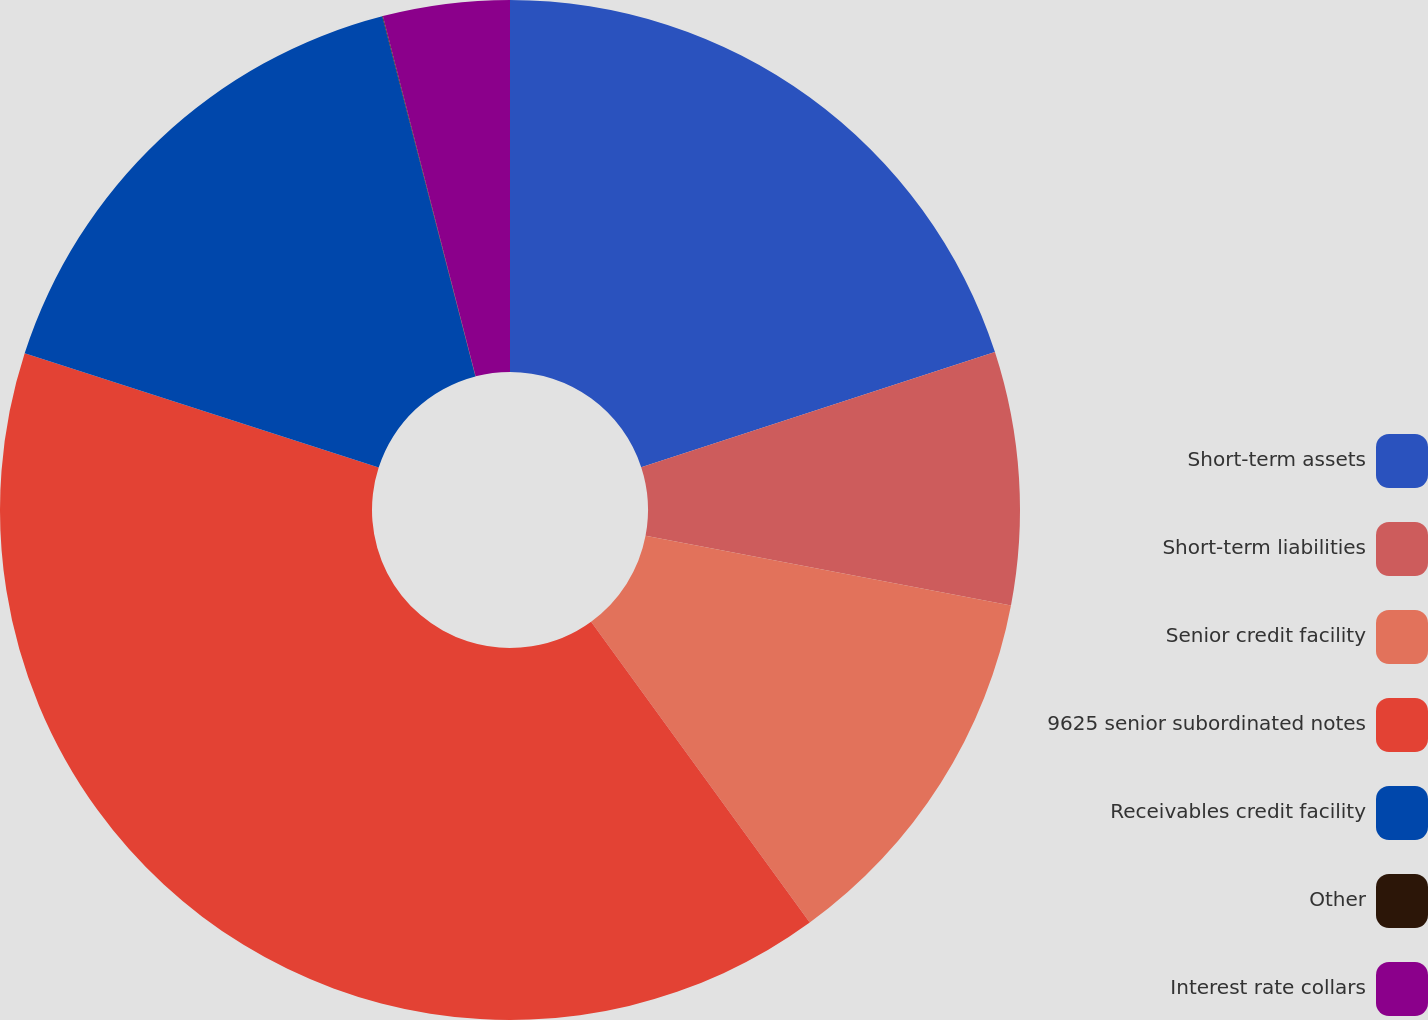Convert chart to OTSL. <chart><loc_0><loc_0><loc_500><loc_500><pie_chart><fcel>Short-term assets<fcel>Short-term liabilities<fcel>Senior credit facility<fcel>9625 senior subordinated notes<fcel>Receivables credit facility<fcel>Other<fcel>Interest rate collars<nl><fcel>19.99%<fcel>8.01%<fcel>12.0%<fcel>39.97%<fcel>16.0%<fcel>0.02%<fcel>4.01%<nl></chart> 